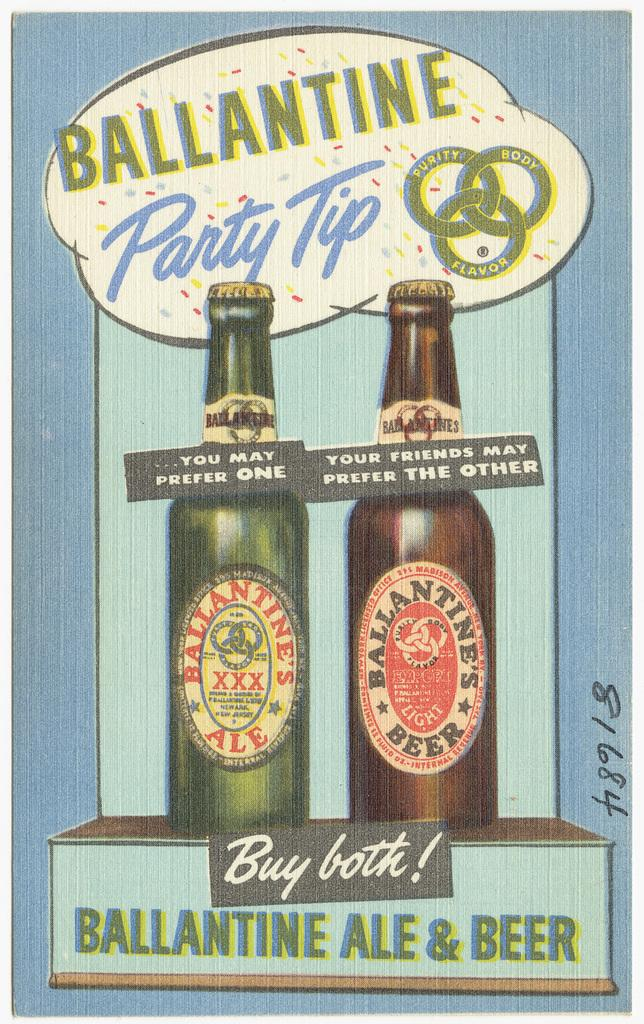<image>
Write a terse but informative summary of the picture. a drawing of two bottles of beer with ballantine ale and beer written on the bottom 